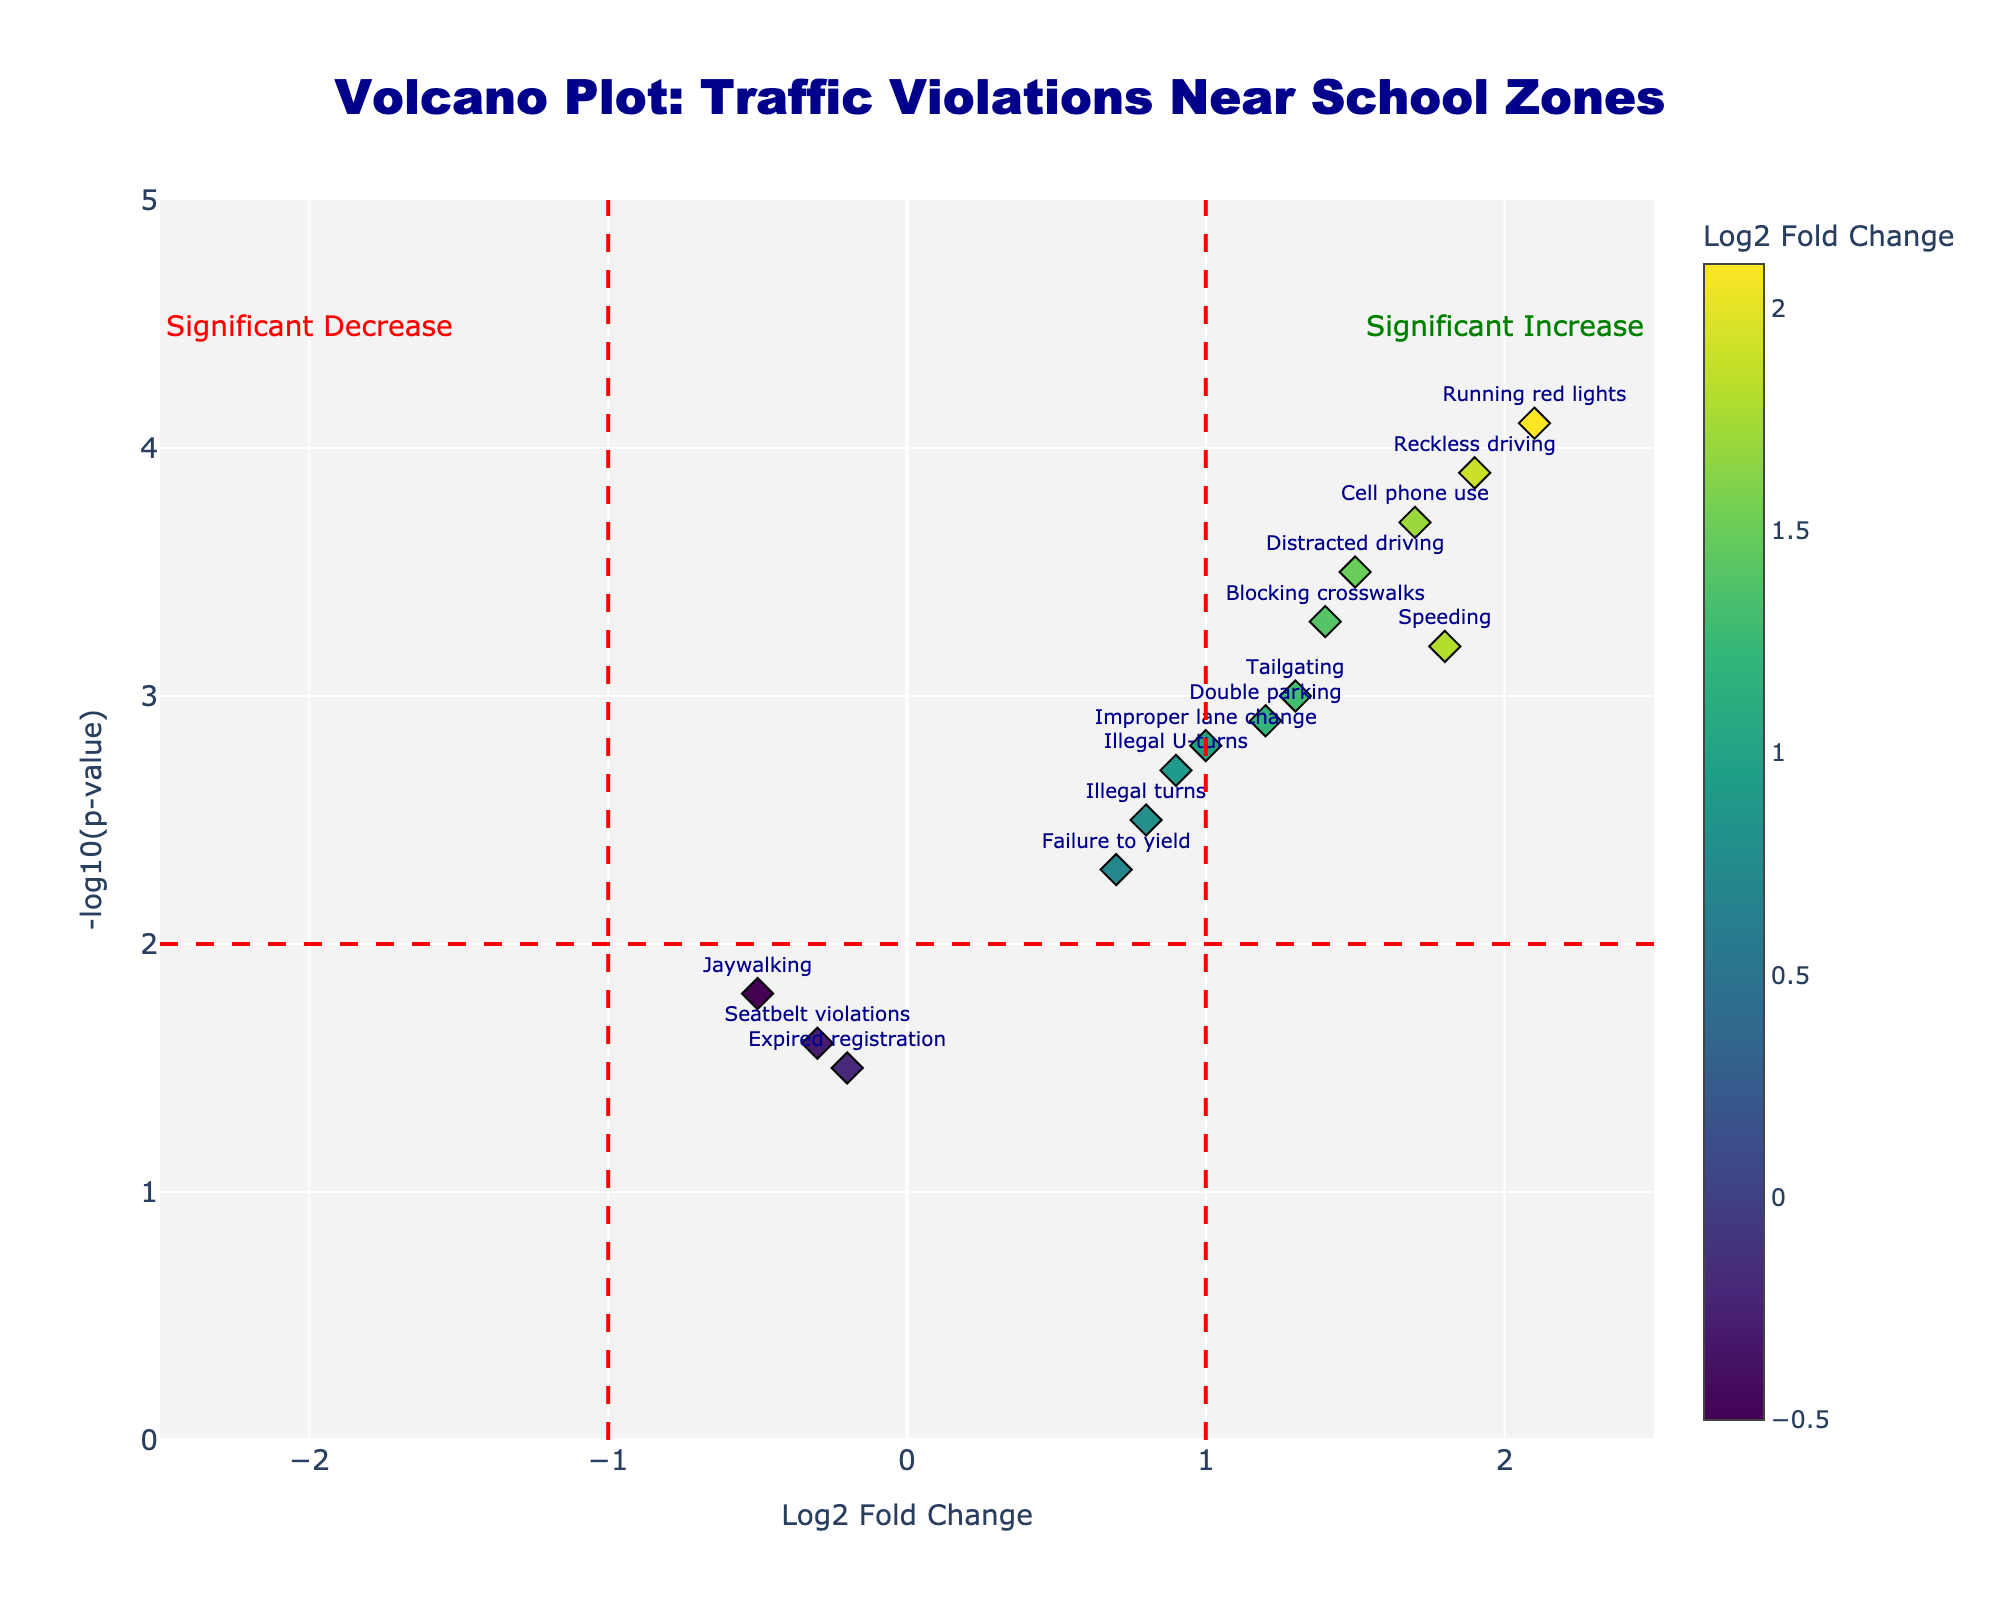What's the title of the figure? The title of a plot is typically found at the top of the plot and is meant to describe the main point of the visualization. In this case, the title is "Volcano Plot: Traffic Violations Near School Zones".
Answer: Volcano Plot: Traffic Violations Near School Zones How many data points are shown on the plot? Each data point represents a type of traffic violation. By counting the points, we can determine there are 15 types of traffic violations shown in the plot.
Answer: 15 Which traffic violation has the highest statistical significance? On a Volcano Plot, statistical significance is presented along the y-axis (-log10(p-value)). The higher the value, the more significant it is. Here, "Running red lights" has the highest -log10(p-value) of 4.1.
Answer: Running red lights Is there any traffic violation type with a Log2FoldChange close to zero? Log2FoldChange is on the x-axis. A value close to zero would be either slightly positive or slightly negative. "Jaywalking" (-0.5) and "Seatbelt violations" (-0.3) are closest to zero.
Answer: Jaywalking and Seatbelt violations Which traffic violation has the highest increase in occurrence? For the highest increase, we look for the highest positive Log2FoldChange. "Running red lights" has the highest Log2FoldChange at 2.1.
Answer: Running red lights Which traffic violations are both highly significant and have large fold changes? Traffic violations that lie in the upper right corner of the plot indicate high significance and large positive fold changes. "Running red lights" (Log2FC 2.1, -log10(p-value) 4.1) and "Reckless driving" (Log2FC 1.9, -log10(p-value) 3.9) fall into this category.
Answer: Running red lights and Reckless driving What is the range of -log10(p-value) represented in the plot? The range can be determined by looking at the y-axis of the plot. The minimum value approaches 1.5, and the maximum value goes up to 4.1. Therefore, the range is approximately from 1.5 to 4.1.
Answer: 1.5 to 4.1 Which data points are below the threshold for statistical significance? The threshold for significance is usually indicated by a horizontal line, here at -log10(p-value) of 2. All points below this line are less significant. This includes "Jaywalking" (1.8), "Seatbelt violations" (1.6), and "Expired registration" (1.5).
Answer: Jaywalking, Seatbelt violations, and Expired registration Which violations are considered insignificant and show a decrease in occurrence? Insignificant violations fall below the horizontal line at -log10(p-value) of 2. Decrease in occurrence is shown by a negative Log2FoldChange. "Seatbelt violations" (-0.3) and "Expired registration" (-0.2) fall into this category.
Answer: Seatbelt violations and Expired registration 